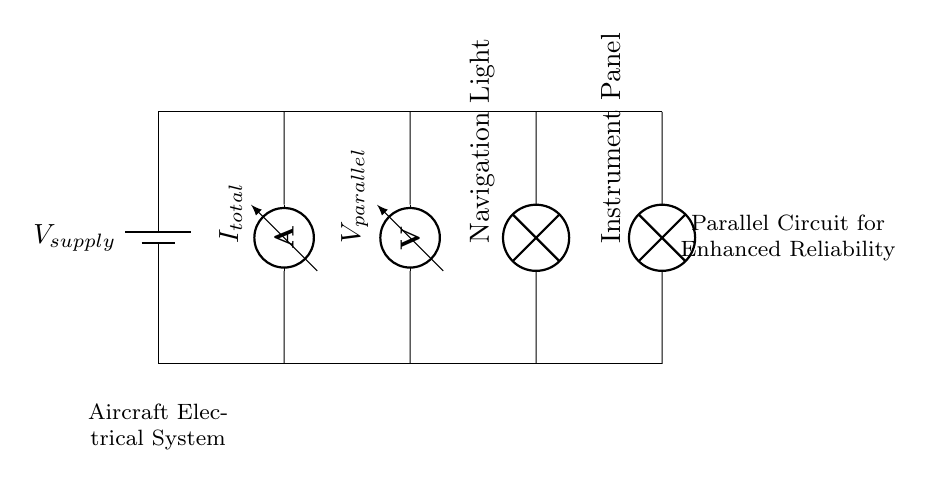What is the total current in the circuit? The total current is represented by the ammeter in the circuit, denoted as I_total. Since exact values are not provided in the diagram, it indicates that the current flows through the parallel branches.
Answer: I_total What is the voltage across the parallel components? The voltage reading is indicated by the voltmeter, marked as V_parallel. In a parallel circuit, all components share the same voltage, which is the supply voltage in the circuit.
Answer: V_parallel How many lamps are present in this circuit? Two lamps are present in the circuit: one for the navigation light and one for the instrument panel. Each lamp is connected in parallel to the power supply.
Answer: Two What is the purpose of the parallel circuit implementation? The purpose of implementing a parallel circuit in this case is to enhance reliability; if one component fails, the others continue operating, allowing critical systems like navigation displays to function without interruption.
Answer: Enhance reliability What kind of circuit is represented in the diagram? The circuit is a parallel circuit, characterized by multiple paths for current flow, where each component operates independently of the others.
Answer: Parallel circuit 